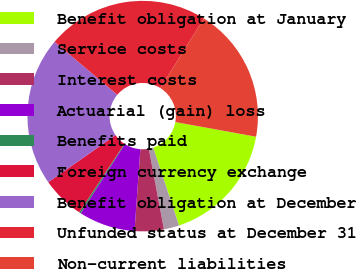Convert chart to OTSL. <chart><loc_0><loc_0><loc_500><loc_500><pie_chart><fcel>Benefit obligation at January<fcel>Service costs<fcel>Interest costs<fcel>Actuarial (gain) loss<fcel>Benefits paid<fcel>Foreign currency exchange<fcel>Benefit obligation at December<fcel>Unfunded status at December 31<fcel>Non-current liabilities<nl><fcel>17.03%<fcel>2.16%<fcel>4.08%<fcel>7.91%<fcel>0.24%<fcel>6.0%<fcel>20.86%<fcel>22.78%<fcel>18.94%<nl></chart> 